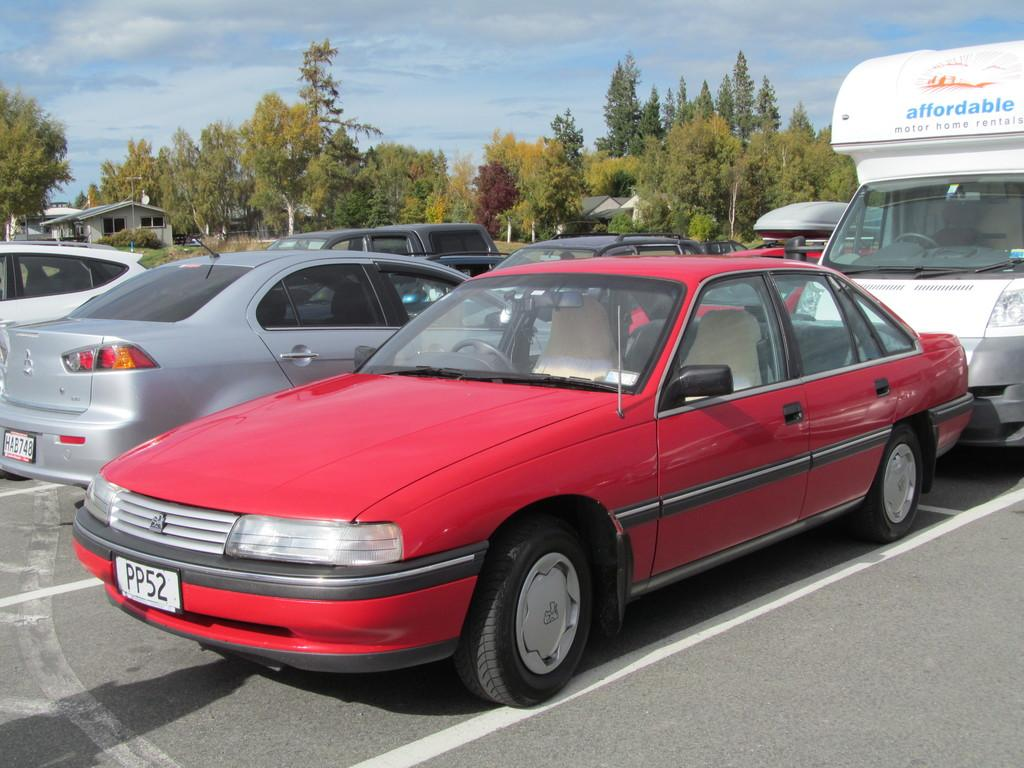What type of view is shown in the image? The image is an outside view. What can be seen on the road in the image? There are many vehicles on the road. What type of vegetation is visible in the background of the image? There are many trees in the background. How many buildings can be seen in the background of the image? There are few buildings in the background. What is visible at the top of the image? The sky is visible at the top of the image. What can be observed in the sky in the image? Clouds are present in the sky. Where is the stick located in the image? There is no stick present in the image. What type of eggs can be seen on the shelf in the image? There is no shelf or eggs present in the image. 